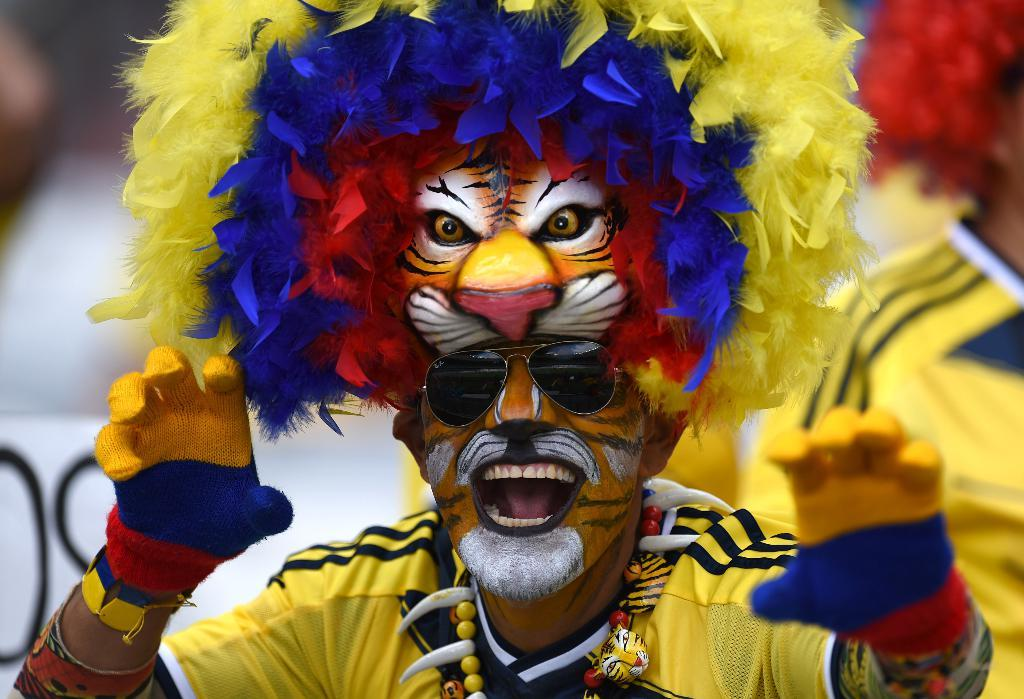What is present in the image? There is a person in the image. What is the person wearing? The person is wearing a costume. Can you describe the background of the image? The background of the image appears blurred. What type of pear can be seen hanging from the costume in the image? There is no pear present in the image, nor is there any pear hanging from the costume. 